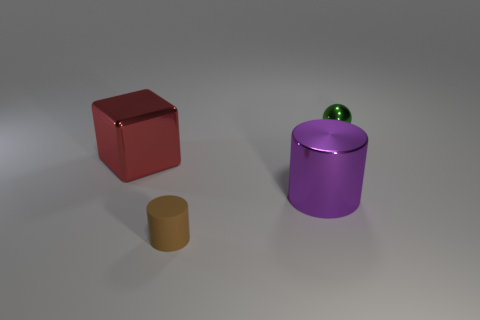How many metallic things are either large blue things or cubes?
Offer a terse response. 1. Does the small thing that is behind the large cube have the same shape as the large shiny thing that is in front of the red metallic object?
Ensure brevity in your answer.  No. What color is the object that is both left of the purple metallic cylinder and on the right side of the big red metal block?
Your response must be concise. Brown. There is a shiny thing to the right of the purple metallic cylinder; is its size the same as the rubber thing that is in front of the big red object?
Keep it short and to the point. Yes. What number of other large cubes are the same color as the cube?
Keep it short and to the point. 0. How many big things are shiny cubes or purple cylinders?
Ensure brevity in your answer.  2. Does the cylinder that is to the left of the large purple thing have the same material as the tiny green object?
Keep it short and to the point. No. The small object in front of the sphere is what color?
Your answer should be compact. Brown. Is there a green object of the same size as the cube?
Your response must be concise. No. There is a red cube that is the same size as the purple metallic object; what material is it?
Ensure brevity in your answer.  Metal. 